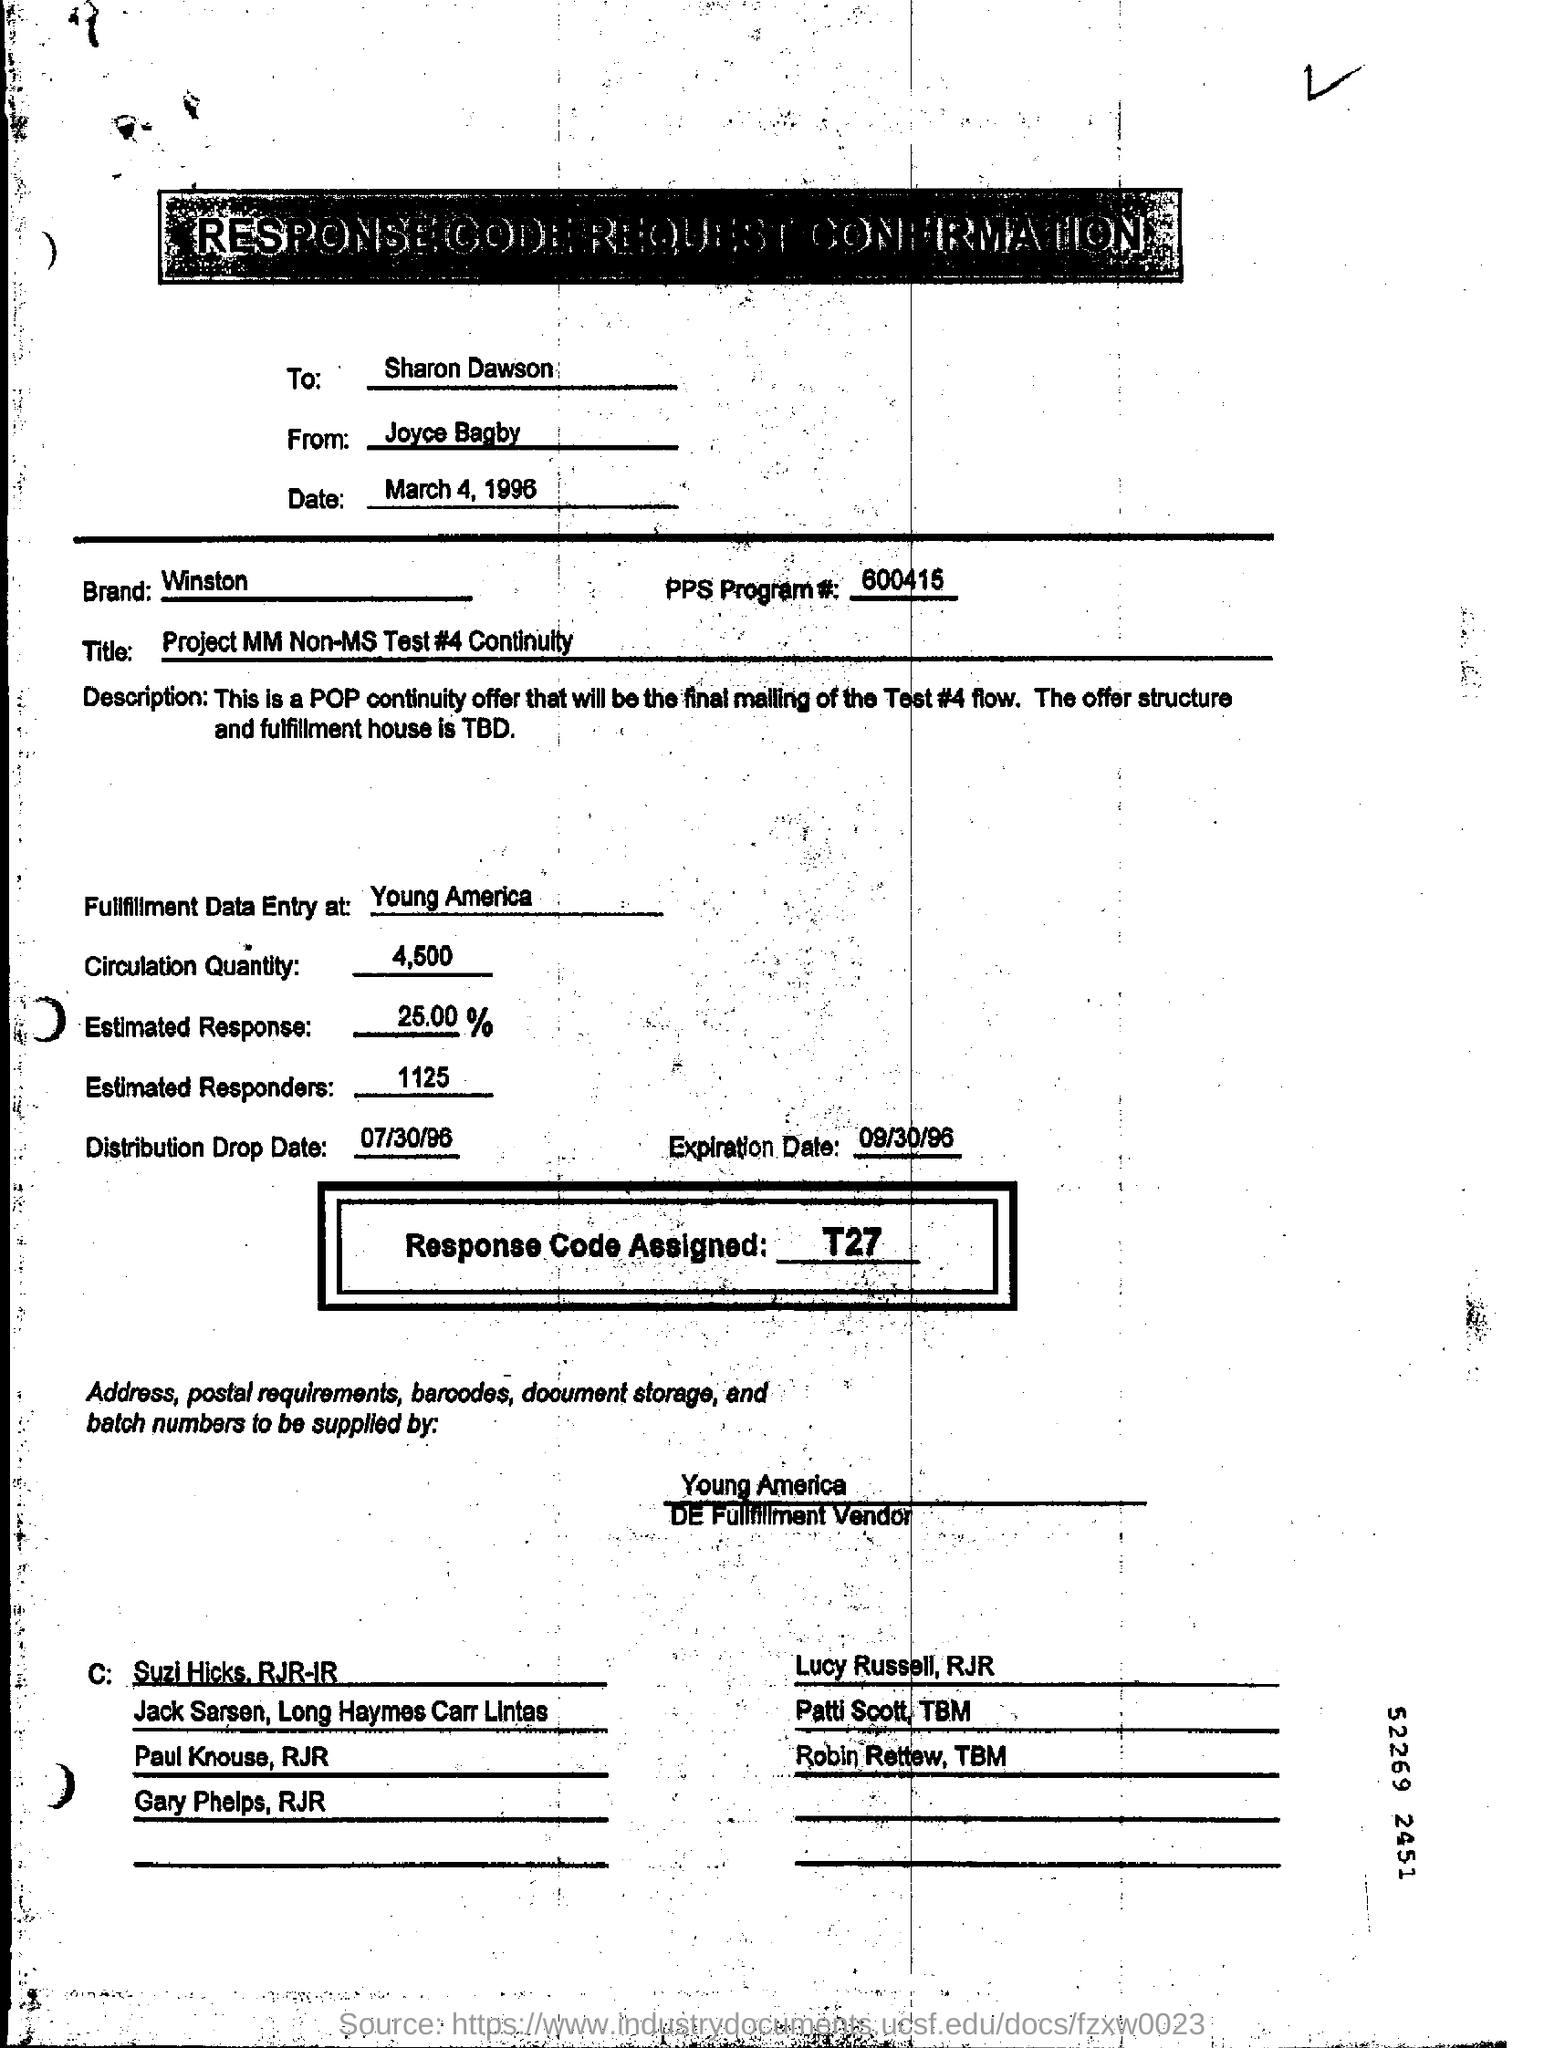Who is it addressed to?
Ensure brevity in your answer.  Sharon Dawson. Who is it From?
Offer a terse response. Joyce Bagby. What is the Date?
Your answer should be very brief. March 4, 1996. What is the Brand?
Offer a very short reply. Winston. What is the PPs Program #?
Offer a very short reply. 600415. Where is the fullfillment data entry at?
Offer a terse response. Young America. What is the Circulation Qty?
Keep it short and to the point. 4,500. What is the Estimated Response?
Ensure brevity in your answer.  25.00  %. What is the Estimated responders?
Keep it short and to the point. 1125. What is the Distribution drop date?
Provide a succinct answer. 07/30/96. What is the expiration date?
Ensure brevity in your answer.  09/30/96. What is the response code assigned?
Offer a very short reply. T27. 